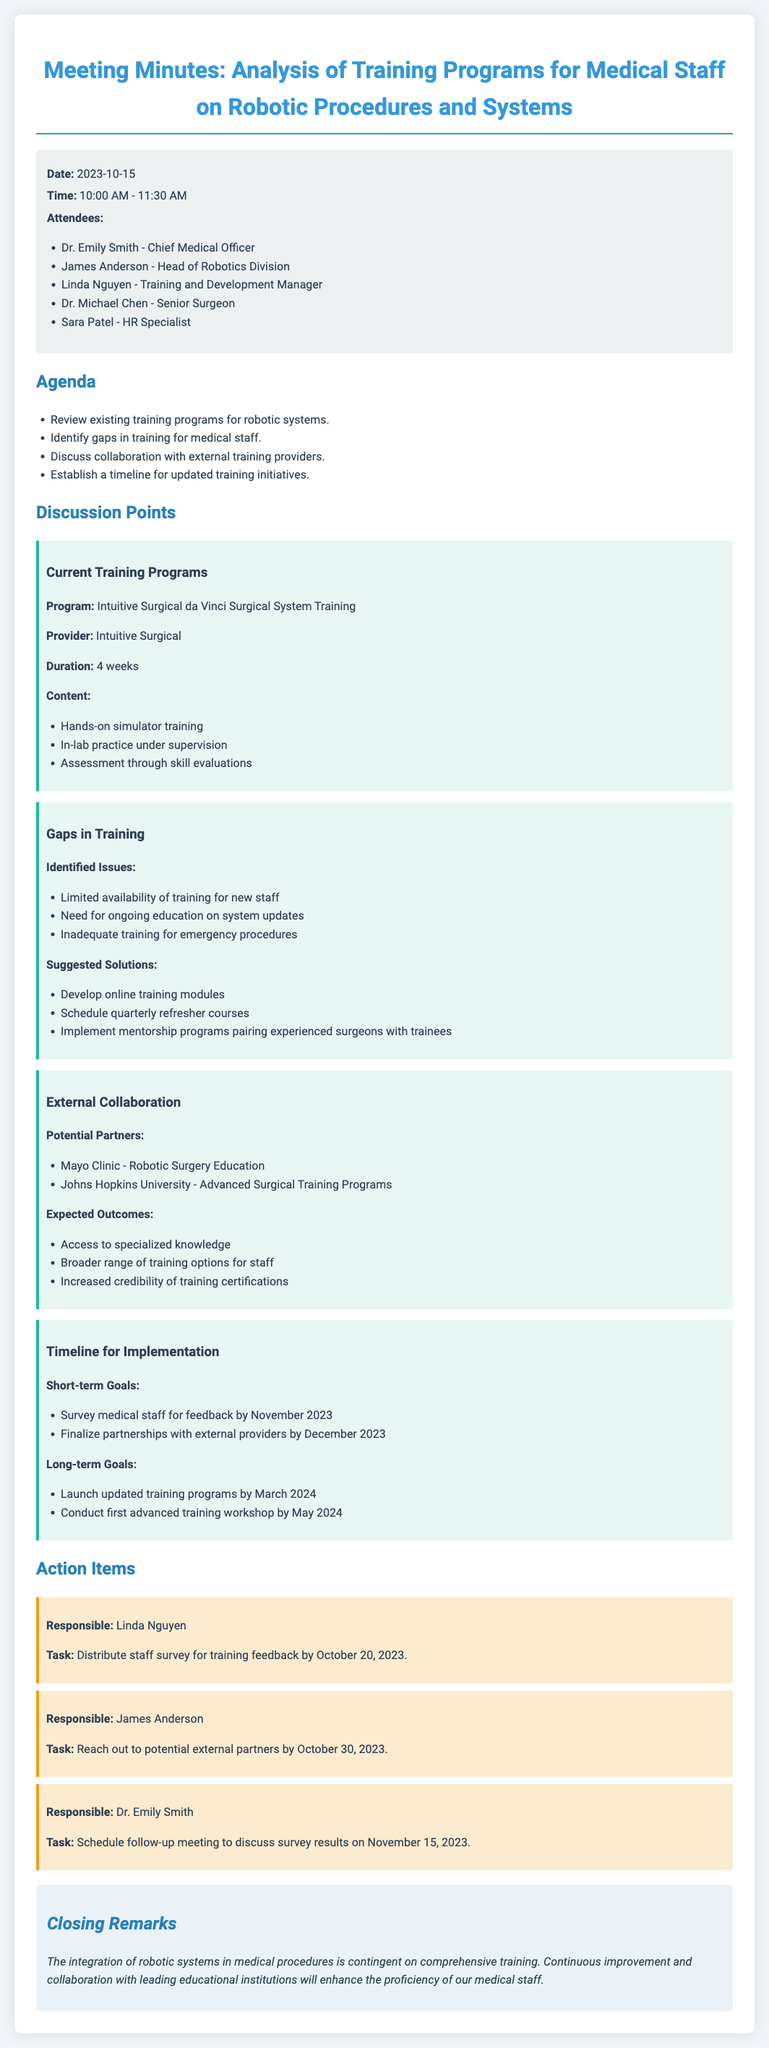what is the date of the meeting? The date of the meeting is specified in the meta information section of the document.
Answer: 2023-10-15 who is the Chief Medical Officer? This role is filled by an attendee listed in the meeting minutes.
Answer: Dr. Emily Smith how long is the current training program for the da Vinci Surgical System? The duration of the training program is mentioned under current training programs in the document.
Answer: 4 weeks what are the identified issues regarding training for medical staff? The issues are specified under the gaps in training section and listed in bullet points.
Answer: Limited availability of training for new staff, need for ongoing education on system updates, inadequate training for emergency procedures which two institutions are mentioned as potential partners for external collaboration? These potential partners are listed in the external collaboration section of the document.
Answer: Mayo Clinic, Johns Hopkins University when is the first advanced training workshop scheduled? The timeline for implementation section provides the date for this event.
Answer: May 2024 what is one suggested solution to address training gaps? Suggested solutions are outlined in the gaps in training section, providing various options.
Answer: Develop online training modules who is responsible for distributing the staff survey? This responsibility is assigned to an attendee in the action items section.
Answer: Linda Nguyen 